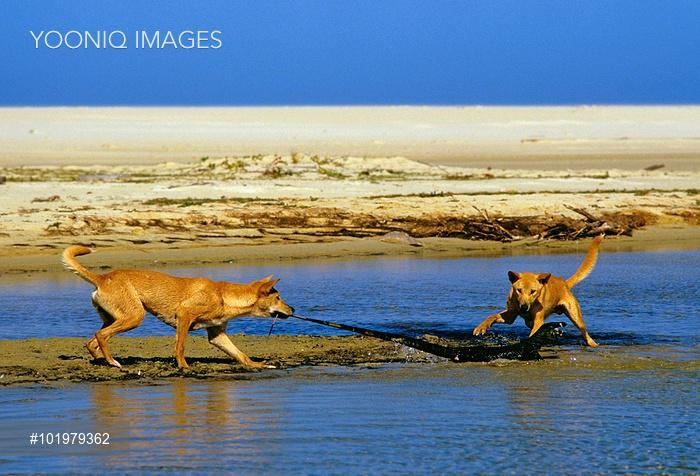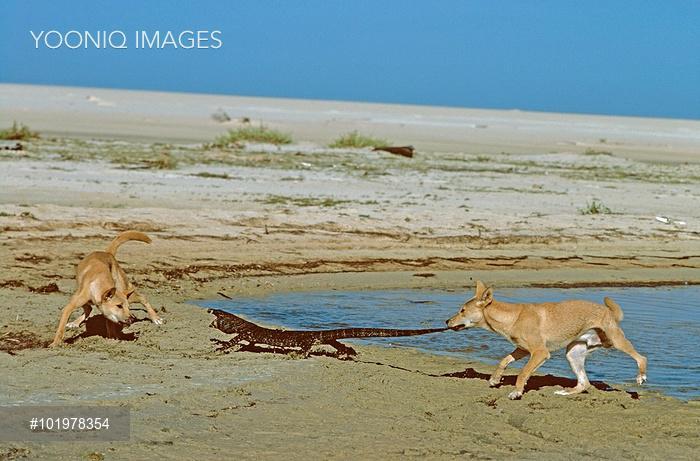The first image is the image on the left, the second image is the image on the right. Analyze the images presented: Is the assertion "In each image there are a pair of dogs on a shore attacking a large lizard." valid? Answer yes or no. Yes. 